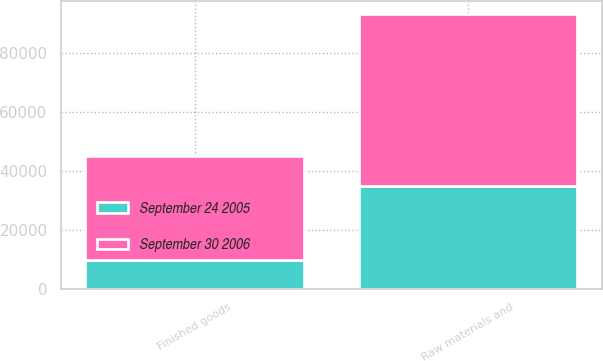Convert chart to OTSL. <chart><loc_0><loc_0><loc_500><loc_500><stacked_bar_chart><ecel><fcel>Raw materials and<fcel>Finished goods<nl><fcel>September 30 2006<fcel>58226<fcel>35251<nl><fcel>September 24 2005<fcel>34714<fcel>9806<nl></chart> 